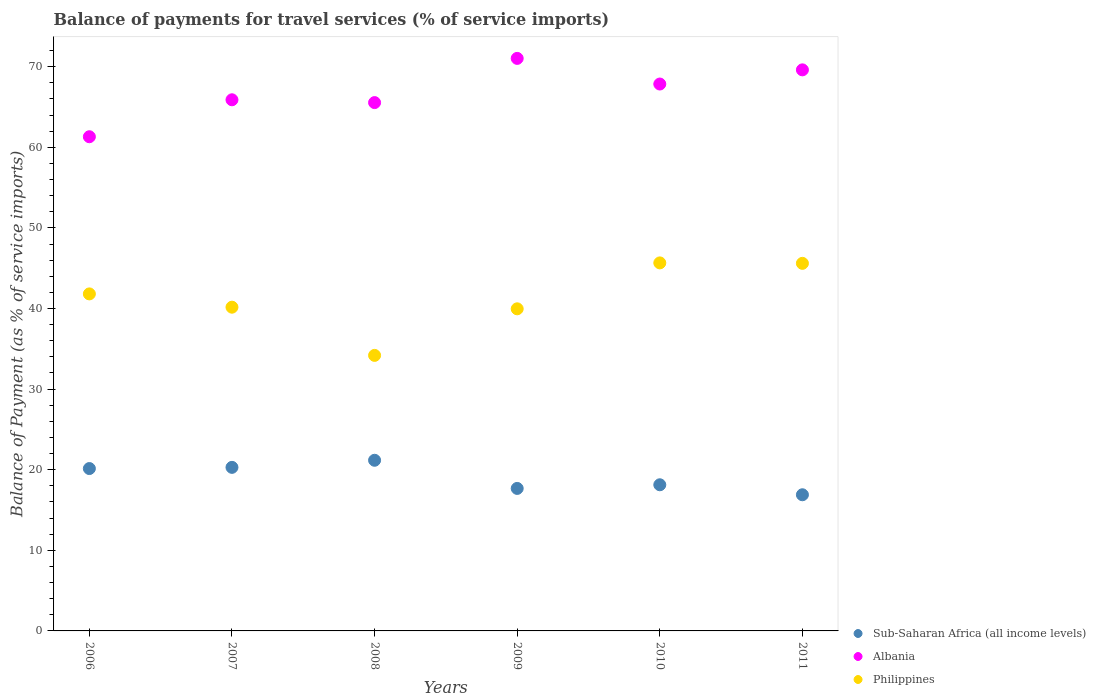What is the balance of payments for travel services in Philippines in 2007?
Provide a short and direct response. 40.16. Across all years, what is the maximum balance of payments for travel services in Philippines?
Ensure brevity in your answer.  45.66. Across all years, what is the minimum balance of payments for travel services in Sub-Saharan Africa (all income levels)?
Provide a short and direct response. 16.89. In which year was the balance of payments for travel services in Albania maximum?
Provide a short and direct response. 2009. What is the total balance of payments for travel services in Sub-Saharan Africa (all income levels) in the graph?
Your answer should be very brief. 114.31. What is the difference between the balance of payments for travel services in Philippines in 2009 and that in 2010?
Provide a short and direct response. -5.7. What is the difference between the balance of payments for travel services in Philippines in 2006 and the balance of payments for travel services in Albania in 2009?
Offer a terse response. -29.22. What is the average balance of payments for travel services in Philippines per year?
Provide a short and direct response. 41.23. In the year 2010, what is the difference between the balance of payments for travel services in Philippines and balance of payments for travel services in Sub-Saharan Africa (all income levels)?
Make the answer very short. 27.53. What is the ratio of the balance of payments for travel services in Philippines in 2007 to that in 2009?
Make the answer very short. 1.01. Is the balance of payments for travel services in Sub-Saharan Africa (all income levels) in 2007 less than that in 2008?
Provide a short and direct response. Yes. Is the difference between the balance of payments for travel services in Philippines in 2006 and 2011 greater than the difference between the balance of payments for travel services in Sub-Saharan Africa (all income levels) in 2006 and 2011?
Your response must be concise. No. What is the difference between the highest and the second highest balance of payments for travel services in Sub-Saharan Africa (all income levels)?
Ensure brevity in your answer.  0.88. What is the difference between the highest and the lowest balance of payments for travel services in Sub-Saharan Africa (all income levels)?
Offer a very short reply. 4.28. Does the balance of payments for travel services in Philippines monotonically increase over the years?
Make the answer very short. No. Is the balance of payments for travel services in Philippines strictly greater than the balance of payments for travel services in Sub-Saharan Africa (all income levels) over the years?
Your answer should be compact. Yes. Is the balance of payments for travel services in Philippines strictly less than the balance of payments for travel services in Sub-Saharan Africa (all income levels) over the years?
Ensure brevity in your answer.  No. How many years are there in the graph?
Provide a succinct answer. 6. Does the graph contain grids?
Ensure brevity in your answer.  No. Where does the legend appear in the graph?
Keep it short and to the point. Bottom right. How many legend labels are there?
Keep it short and to the point. 3. What is the title of the graph?
Offer a very short reply. Balance of payments for travel services (% of service imports). What is the label or title of the X-axis?
Your answer should be very brief. Years. What is the label or title of the Y-axis?
Make the answer very short. Balance of Payment (as % of service imports). What is the Balance of Payment (as % of service imports) in Sub-Saharan Africa (all income levels) in 2006?
Your answer should be very brief. 20.14. What is the Balance of Payment (as % of service imports) of Albania in 2006?
Offer a terse response. 61.31. What is the Balance of Payment (as % of service imports) in Philippines in 2006?
Offer a very short reply. 41.81. What is the Balance of Payment (as % of service imports) of Sub-Saharan Africa (all income levels) in 2007?
Provide a succinct answer. 20.29. What is the Balance of Payment (as % of service imports) of Albania in 2007?
Offer a very short reply. 65.89. What is the Balance of Payment (as % of service imports) of Philippines in 2007?
Keep it short and to the point. 40.16. What is the Balance of Payment (as % of service imports) in Sub-Saharan Africa (all income levels) in 2008?
Provide a succinct answer. 21.17. What is the Balance of Payment (as % of service imports) in Albania in 2008?
Your answer should be compact. 65.54. What is the Balance of Payment (as % of service imports) in Philippines in 2008?
Your answer should be compact. 34.18. What is the Balance of Payment (as % of service imports) in Sub-Saharan Africa (all income levels) in 2009?
Keep it short and to the point. 17.68. What is the Balance of Payment (as % of service imports) in Albania in 2009?
Ensure brevity in your answer.  71.03. What is the Balance of Payment (as % of service imports) of Philippines in 2009?
Your answer should be very brief. 39.96. What is the Balance of Payment (as % of service imports) of Sub-Saharan Africa (all income levels) in 2010?
Give a very brief answer. 18.13. What is the Balance of Payment (as % of service imports) of Albania in 2010?
Your answer should be very brief. 67.85. What is the Balance of Payment (as % of service imports) in Philippines in 2010?
Make the answer very short. 45.66. What is the Balance of Payment (as % of service imports) of Sub-Saharan Africa (all income levels) in 2011?
Offer a terse response. 16.89. What is the Balance of Payment (as % of service imports) in Albania in 2011?
Your answer should be very brief. 69.61. What is the Balance of Payment (as % of service imports) of Philippines in 2011?
Your answer should be compact. 45.6. Across all years, what is the maximum Balance of Payment (as % of service imports) in Sub-Saharan Africa (all income levels)?
Offer a terse response. 21.17. Across all years, what is the maximum Balance of Payment (as % of service imports) in Albania?
Provide a short and direct response. 71.03. Across all years, what is the maximum Balance of Payment (as % of service imports) of Philippines?
Your answer should be very brief. 45.66. Across all years, what is the minimum Balance of Payment (as % of service imports) in Sub-Saharan Africa (all income levels)?
Provide a succinct answer. 16.89. Across all years, what is the minimum Balance of Payment (as % of service imports) of Albania?
Keep it short and to the point. 61.31. Across all years, what is the minimum Balance of Payment (as % of service imports) in Philippines?
Offer a very short reply. 34.18. What is the total Balance of Payment (as % of service imports) of Sub-Saharan Africa (all income levels) in the graph?
Offer a very short reply. 114.31. What is the total Balance of Payment (as % of service imports) in Albania in the graph?
Keep it short and to the point. 401.23. What is the total Balance of Payment (as % of service imports) in Philippines in the graph?
Keep it short and to the point. 247.38. What is the difference between the Balance of Payment (as % of service imports) in Sub-Saharan Africa (all income levels) in 2006 and that in 2007?
Provide a succinct answer. -0.15. What is the difference between the Balance of Payment (as % of service imports) in Albania in 2006 and that in 2007?
Keep it short and to the point. -4.58. What is the difference between the Balance of Payment (as % of service imports) of Philippines in 2006 and that in 2007?
Make the answer very short. 1.65. What is the difference between the Balance of Payment (as % of service imports) in Sub-Saharan Africa (all income levels) in 2006 and that in 2008?
Your response must be concise. -1.03. What is the difference between the Balance of Payment (as % of service imports) of Albania in 2006 and that in 2008?
Ensure brevity in your answer.  -4.24. What is the difference between the Balance of Payment (as % of service imports) of Philippines in 2006 and that in 2008?
Keep it short and to the point. 7.63. What is the difference between the Balance of Payment (as % of service imports) of Sub-Saharan Africa (all income levels) in 2006 and that in 2009?
Your answer should be very brief. 2.47. What is the difference between the Balance of Payment (as % of service imports) of Albania in 2006 and that in 2009?
Give a very brief answer. -9.72. What is the difference between the Balance of Payment (as % of service imports) in Philippines in 2006 and that in 2009?
Provide a succinct answer. 1.85. What is the difference between the Balance of Payment (as % of service imports) in Sub-Saharan Africa (all income levels) in 2006 and that in 2010?
Offer a very short reply. 2.01. What is the difference between the Balance of Payment (as % of service imports) of Albania in 2006 and that in 2010?
Provide a succinct answer. -6.54. What is the difference between the Balance of Payment (as % of service imports) in Philippines in 2006 and that in 2010?
Your answer should be compact. -3.85. What is the difference between the Balance of Payment (as % of service imports) in Sub-Saharan Africa (all income levels) in 2006 and that in 2011?
Offer a very short reply. 3.25. What is the difference between the Balance of Payment (as % of service imports) of Albania in 2006 and that in 2011?
Provide a succinct answer. -8.3. What is the difference between the Balance of Payment (as % of service imports) of Philippines in 2006 and that in 2011?
Your answer should be compact. -3.79. What is the difference between the Balance of Payment (as % of service imports) of Sub-Saharan Africa (all income levels) in 2007 and that in 2008?
Make the answer very short. -0.88. What is the difference between the Balance of Payment (as % of service imports) of Albania in 2007 and that in 2008?
Keep it short and to the point. 0.35. What is the difference between the Balance of Payment (as % of service imports) in Philippines in 2007 and that in 2008?
Offer a terse response. 5.98. What is the difference between the Balance of Payment (as % of service imports) of Sub-Saharan Africa (all income levels) in 2007 and that in 2009?
Make the answer very short. 2.61. What is the difference between the Balance of Payment (as % of service imports) of Albania in 2007 and that in 2009?
Your answer should be compact. -5.14. What is the difference between the Balance of Payment (as % of service imports) of Philippines in 2007 and that in 2009?
Offer a very short reply. 0.2. What is the difference between the Balance of Payment (as % of service imports) in Sub-Saharan Africa (all income levels) in 2007 and that in 2010?
Keep it short and to the point. 2.16. What is the difference between the Balance of Payment (as % of service imports) in Albania in 2007 and that in 2010?
Ensure brevity in your answer.  -1.96. What is the difference between the Balance of Payment (as % of service imports) of Philippines in 2007 and that in 2010?
Your answer should be compact. -5.5. What is the difference between the Balance of Payment (as % of service imports) of Sub-Saharan Africa (all income levels) in 2007 and that in 2011?
Give a very brief answer. 3.4. What is the difference between the Balance of Payment (as % of service imports) of Albania in 2007 and that in 2011?
Your response must be concise. -3.71. What is the difference between the Balance of Payment (as % of service imports) of Philippines in 2007 and that in 2011?
Offer a terse response. -5.44. What is the difference between the Balance of Payment (as % of service imports) of Sub-Saharan Africa (all income levels) in 2008 and that in 2009?
Offer a very short reply. 3.49. What is the difference between the Balance of Payment (as % of service imports) in Albania in 2008 and that in 2009?
Ensure brevity in your answer.  -5.48. What is the difference between the Balance of Payment (as % of service imports) in Philippines in 2008 and that in 2009?
Ensure brevity in your answer.  -5.78. What is the difference between the Balance of Payment (as % of service imports) in Sub-Saharan Africa (all income levels) in 2008 and that in 2010?
Offer a very short reply. 3.04. What is the difference between the Balance of Payment (as % of service imports) in Albania in 2008 and that in 2010?
Offer a very short reply. -2.3. What is the difference between the Balance of Payment (as % of service imports) in Philippines in 2008 and that in 2010?
Offer a terse response. -11.48. What is the difference between the Balance of Payment (as % of service imports) of Sub-Saharan Africa (all income levels) in 2008 and that in 2011?
Keep it short and to the point. 4.28. What is the difference between the Balance of Payment (as % of service imports) of Albania in 2008 and that in 2011?
Provide a succinct answer. -4.06. What is the difference between the Balance of Payment (as % of service imports) of Philippines in 2008 and that in 2011?
Provide a succinct answer. -11.42. What is the difference between the Balance of Payment (as % of service imports) of Sub-Saharan Africa (all income levels) in 2009 and that in 2010?
Provide a succinct answer. -0.45. What is the difference between the Balance of Payment (as % of service imports) of Albania in 2009 and that in 2010?
Keep it short and to the point. 3.18. What is the difference between the Balance of Payment (as % of service imports) of Philippines in 2009 and that in 2010?
Give a very brief answer. -5.7. What is the difference between the Balance of Payment (as % of service imports) in Sub-Saharan Africa (all income levels) in 2009 and that in 2011?
Provide a short and direct response. 0.79. What is the difference between the Balance of Payment (as % of service imports) of Albania in 2009 and that in 2011?
Offer a terse response. 1.42. What is the difference between the Balance of Payment (as % of service imports) in Philippines in 2009 and that in 2011?
Your answer should be compact. -5.64. What is the difference between the Balance of Payment (as % of service imports) of Sub-Saharan Africa (all income levels) in 2010 and that in 2011?
Provide a short and direct response. 1.24. What is the difference between the Balance of Payment (as % of service imports) in Albania in 2010 and that in 2011?
Ensure brevity in your answer.  -1.76. What is the difference between the Balance of Payment (as % of service imports) of Philippines in 2010 and that in 2011?
Your answer should be compact. 0.06. What is the difference between the Balance of Payment (as % of service imports) in Sub-Saharan Africa (all income levels) in 2006 and the Balance of Payment (as % of service imports) in Albania in 2007?
Ensure brevity in your answer.  -45.75. What is the difference between the Balance of Payment (as % of service imports) of Sub-Saharan Africa (all income levels) in 2006 and the Balance of Payment (as % of service imports) of Philippines in 2007?
Your response must be concise. -20.02. What is the difference between the Balance of Payment (as % of service imports) of Albania in 2006 and the Balance of Payment (as % of service imports) of Philippines in 2007?
Offer a very short reply. 21.15. What is the difference between the Balance of Payment (as % of service imports) in Sub-Saharan Africa (all income levels) in 2006 and the Balance of Payment (as % of service imports) in Albania in 2008?
Your answer should be very brief. -45.4. What is the difference between the Balance of Payment (as % of service imports) in Sub-Saharan Africa (all income levels) in 2006 and the Balance of Payment (as % of service imports) in Philippines in 2008?
Your response must be concise. -14.04. What is the difference between the Balance of Payment (as % of service imports) of Albania in 2006 and the Balance of Payment (as % of service imports) of Philippines in 2008?
Offer a terse response. 27.13. What is the difference between the Balance of Payment (as % of service imports) of Sub-Saharan Africa (all income levels) in 2006 and the Balance of Payment (as % of service imports) of Albania in 2009?
Provide a succinct answer. -50.88. What is the difference between the Balance of Payment (as % of service imports) in Sub-Saharan Africa (all income levels) in 2006 and the Balance of Payment (as % of service imports) in Philippines in 2009?
Provide a succinct answer. -19.82. What is the difference between the Balance of Payment (as % of service imports) in Albania in 2006 and the Balance of Payment (as % of service imports) in Philippines in 2009?
Provide a short and direct response. 21.35. What is the difference between the Balance of Payment (as % of service imports) of Sub-Saharan Africa (all income levels) in 2006 and the Balance of Payment (as % of service imports) of Albania in 2010?
Ensure brevity in your answer.  -47.7. What is the difference between the Balance of Payment (as % of service imports) in Sub-Saharan Africa (all income levels) in 2006 and the Balance of Payment (as % of service imports) in Philippines in 2010?
Keep it short and to the point. -25.51. What is the difference between the Balance of Payment (as % of service imports) in Albania in 2006 and the Balance of Payment (as % of service imports) in Philippines in 2010?
Keep it short and to the point. 15.65. What is the difference between the Balance of Payment (as % of service imports) of Sub-Saharan Africa (all income levels) in 2006 and the Balance of Payment (as % of service imports) of Albania in 2011?
Ensure brevity in your answer.  -49.46. What is the difference between the Balance of Payment (as % of service imports) in Sub-Saharan Africa (all income levels) in 2006 and the Balance of Payment (as % of service imports) in Philippines in 2011?
Offer a very short reply. -25.46. What is the difference between the Balance of Payment (as % of service imports) in Albania in 2006 and the Balance of Payment (as % of service imports) in Philippines in 2011?
Ensure brevity in your answer.  15.71. What is the difference between the Balance of Payment (as % of service imports) of Sub-Saharan Africa (all income levels) in 2007 and the Balance of Payment (as % of service imports) of Albania in 2008?
Ensure brevity in your answer.  -45.25. What is the difference between the Balance of Payment (as % of service imports) in Sub-Saharan Africa (all income levels) in 2007 and the Balance of Payment (as % of service imports) in Philippines in 2008?
Make the answer very short. -13.89. What is the difference between the Balance of Payment (as % of service imports) of Albania in 2007 and the Balance of Payment (as % of service imports) of Philippines in 2008?
Offer a terse response. 31.71. What is the difference between the Balance of Payment (as % of service imports) in Sub-Saharan Africa (all income levels) in 2007 and the Balance of Payment (as % of service imports) in Albania in 2009?
Make the answer very short. -50.74. What is the difference between the Balance of Payment (as % of service imports) in Sub-Saharan Africa (all income levels) in 2007 and the Balance of Payment (as % of service imports) in Philippines in 2009?
Provide a succinct answer. -19.67. What is the difference between the Balance of Payment (as % of service imports) in Albania in 2007 and the Balance of Payment (as % of service imports) in Philippines in 2009?
Your answer should be very brief. 25.93. What is the difference between the Balance of Payment (as % of service imports) in Sub-Saharan Africa (all income levels) in 2007 and the Balance of Payment (as % of service imports) in Albania in 2010?
Provide a short and direct response. -47.56. What is the difference between the Balance of Payment (as % of service imports) of Sub-Saharan Africa (all income levels) in 2007 and the Balance of Payment (as % of service imports) of Philippines in 2010?
Provide a succinct answer. -25.37. What is the difference between the Balance of Payment (as % of service imports) of Albania in 2007 and the Balance of Payment (as % of service imports) of Philippines in 2010?
Ensure brevity in your answer.  20.23. What is the difference between the Balance of Payment (as % of service imports) in Sub-Saharan Africa (all income levels) in 2007 and the Balance of Payment (as % of service imports) in Albania in 2011?
Offer a terse response. -49.31. What is the difference between the Balance of Payment (as % of service imports) in Sub-Saharan Africa (all income levels) in 2007 and the Balance of Payment (as % of service imports) in Philippines in 2011?
Provide a short and direct response. -25.31. What is the difference between the Balance of Payment (as % of service imports) in Albania in 2007 and the Balance of Payment (as % of service imports) in Philippines in 2011?
Your answer should be very brief. 20.29. What is the difference between the Balance of Payment (as % of service imports) in Sub-Saharan Africa (all income levels) in 2008 and the Balance of Payment (as % of service imports) in Albania in 2009?
Make the answer very short. -49.86. What is the difference between the Balance of Payment (as % of service imports) of Sub-Saharan Africa (all income levels) in 2008 and the Balance of Payment (as % of service imports) of Philippines in 2009?
Make the answer very short. -18.79. What is the difference between the Balance of Payment (as % of service imports) in Albania in 2008 and the Balance of Payment (as % of service imports) in Philippines in 2009?
Provide a short and direct response. 25.58. What is the difference between the Balance of Payment (as % of service imports) of Sub-Saharan Africa (all income levels) in 2008 and the Balance of Payment (as % of service imports) of Albania in 2010?
Your answer should be very brief. -46.68. What is the difference between the Balance of Payment (as % of service imports) in Sub-Saharan Africa (all income levels) in 2008 and the Balance of Payment (as % of service imports) in Philippines in 2010?
Offer a terse response. -24.49. What is the difference between the Balance of Payment (as % of service imports) of Albania in 2008 and the Balance of Payment (as % of service imports) of Philippines in 2010?
Make the answer very short. 19.89. What is the difference between the Balance of Payment (as % of service imports) of Sub-Saharan Africa (all income levels) in 2008 and the Balance of Payment (as % of service imports) of Albania in 2011?
Offer a terse response. -48.43. What is the difference between the Balance of Payment (as % of service imports) in Sub-Saharan Africa (all income levels) in 2008 and the Balance of Payment (as % of service imports) in Philippines in 2011?
Your answer should be very brief. -24.43. What is the difference between the Balance of Payment (as % of service imports) in Albania in 2008 and the Balance of Payment (as % of service imports) in Philippines in 2011?
Your answer should be compact. 19.94. What is the difference between the Balance of Payment (as % of service imports) of Sub-Saharan Africa (all income levels) in 2009 and the Balance of Payment (as % of service imports) of Albania in 2010?
Keep it short and to the point. -50.17. What is the difference between the Balance of Payment (as % of service imports) in Sub-Saharan Africa (all income levels) in 2009 and the Balance of Payment (as % of service imports) in Philippines in 2010?
Your answer should be compact. -27.98. What is the difference between the Balance of Payment (as % of service imports) in Albania in 2009 and the Balance of Payment (as % of service imports) in Philippines in 2010?
Provide a succinct answer. 25.37. What is the difference between the Balance of Payment (as % of service imports) of Sub-Saharan Africa (all income levels) in 2009 and the Balance of Payment (as % of service imports) of Albania in 2011?
Your answer should be very brief. -51.93. What is the difference between the Balance of Payment (as % of service imports) in Sub-Saharan Africa (all income levels) in 2009 and the Balance of Payment (as % of service imports) in Philippines in 2011?
Make the answer very short. -27.92. What is the difference between the Balance of Payment (as % of service imports) of Albania in 2009 and the Balance of Payment (as % of service imports) of Philippines in 2011?
Your answer should be very brief. 25.43. What is the difference between the Balance of Payment (as % of service imports) of Sub-Saharan Africa (all income levels) in 2010 and the Balance of Payment (as % of service imports) of Albania in 2011?
Make the answer very short. -51.48. What is the difference between the Balance of Payment (as % of service imports) of Sub-Saharan Africa (all income levels) in 2010 and the Balance of Payment (as % of service imports) of Philippines in 2011?
Give a very brief answer. -27.47. What is the difference between the Balance of Payment (as % of service imports) of Albania in 2010 and the Balance of Payment (as % of service imports) of Philippines in 2011?
Your answer should be compact. 22.25. What is the average Balance of Payment (as % of service imports) in Sub-Saharan Africa (all income levels) per year?
Offer a very short reply. 19.05. What is the average Balance of Payment (as % of service imports) of Albania per year?
Give a very brief answer. 66.87. What is the average Balance of Payment (as % of service imports) in Philippines per year?
Provide a succinct answer. 41.23. In the year 2006, what is the difference between the Balance of Payment (as % of service imports) in Sub-Saharan Africa (all income levels) and Balance of Payment (as % of service imports) in Albania?
Offer a very short reply. -41.16. In the year 2006, what is the difference between the Balance of Payment (as % of service imports) in Sub-Saharan Africa (all income levels) and Balance of Payment (as % of service imports) in Philippines?
Your answer should be very brief. -21.67. In the year 2006, what is the difference between the Balance of Payment (as % of service imports) in Albania and Balance of Payment (as % of service imports) in Philippines?
Give a very brief answer. 19.5. In the year 2007, what is the difference between the Balance of Payment (as % of service imports) of Sub-Saharan Africa (all income levels) and Balance of Payment (as % of service imports) of Albania?
Your response must be concise. -45.6. In the year 2007, what is the difference between the Balance of Payment (as % of service imports) of Sub-Saharan Africa (all income levels) and Balance of Payment (as % of service imports) of Philippines?
Provide a short and direct response. -19.87. In the year 2007, what is the difference between the Balance of Payment (as % of service imports) of Albania and Balance of Payment (as % of service imports) of Philippines?
Provide a short and direct response. 25.73. In the year 2008, what is the difference between the Balance of Payment (as % of service imports) in Sub-Saharan Africa (all income levels) and Balance of Payment (as % of service imports) in Albania?
Provide a succinct answer. -44.37. In the year 2008, what is the difference between the Balance of Payment (as % of service imports) in Sub-Saharan Africa (all income levels) and Balance of Payment (as % of service imports) in Philippines?
Your answer should be very brief. -13.01. In the year 2008, what is the difference between the Balance of Payment (as % of service imports) of Albania and Balance of Payment (as % of service imports) of Philippines?
Provide a succinct answer. 31.36. In the year 2009, what is the difference between the Balance of Payment (as % of service imports) of Sub-Saharan Africa (all income levels) and Balance of Payment (as % of service imports) of Albania?
Provide a succinct answer. -53.35. In the year 2009, what is the difference between the Balance of Payment (as % of service imports) of Sub-Saharan Africa (all income levels) and Balance of Payment (as % of service imports) of Philippines?
Ensure brevity in your answer.  -22.28. In the year 2009, what is the difference between the Balance of Payment (as % of service imports) of Albania and Balance of Payment (as % of service imports) of Philippines?
Make the answer very short. 31.07. In the year 2010, what is the difference between the Balance of Payment (as % of service imports) of Sub-Saharan Africa (all income levels) and Balance of Payment (as % of service imports) of Albania?
Provide a short and direct response. -49.72. In the year 2010, what is the difference between the Balance of Payment (as % of service imports) of Sub-Saharan Africa (all income levels) and Balance of Payment (as % of service imports) of Philippines?
Give a very brief answer. -27.53. In the year 2010, what is the difference between the Balance of Payment (as % of service imports) of Albania and Balance of Payment (as % of service imports) of Philippines?
Keep it short and to the point. 22.19. In the year 2011, what is the difference between the Balance of Payment (as % of service imports) in Sub-Saharan Africa (all income levels) and Balance of Payment (as % of service imports) in Albania?
Your answer should be very brief. -52.71. In the year 2011, what is the difference between the Balance of Payment (as % of service imports) in Sub-Saharan Africa (all income levels) and Balance of Payment (as % of service imports) in Philippines?
Offer a very short reply. -28.71. In the year 2011, what is the difference between the Balance of Payment (as % of service imports) of Albania and Balance of Payment (as % of service imports) of Philippines?
Keep it short and to the point. 24. What is the ratio of the Balance of Payment (as % of service imports) of Sub-Saharan Africa (all income levels) in 2006 to that in 2007?
Your answer should be compact. 0.99. What is the ratio of the Balance of Payment (as % of service imports) of Albania in 2006 to that in 2007?
Your answer should be compact. 0.93. What is the ratio of the Balance of Payment (as % of service imports) of Philippines in 2006 to that in 2007?
Your answer should be very brief. 1.04. What is the ratio of the Balance of Payment (as % of service imports) of Sub-Saharan Africa (all income levels) in 2006 to that in 2008?
Your response must be concise. 0.95. What is the ratio of the Balance of Payment (as % of service imports) of Albania in 2006 to that in 2008?
Your response must be concise. 0.94. What is the ratio of the Balance of Payment (as % of service imports) of Philippines in 2006 to that in 2008?
Provide a succinct answer. 1.22. What is the ratio of the Balance of Payment (as % of service imports) in Sub-Saharan Africa (all income levels) in 2006 to that in 2009?
Offer a very short reply. 1.14. What is the ratio of the Balance of Payment (as % of service imports) in Albania in 2006 to that in 2009?
Provide a short and direct response. 0.86. What is the ratio of the Balance of Payment (as % of service imports) in Philippines in 2006 to that in 2009?
Keep it short and to the point. 1.05. What is the ratio of the Balance of Payment (as % of service imports) of Sub-Saharan Africa (all income levels) in 2006 to that in 2010?
Give a very brief answer. 1.11. What is the ratio of the Balance of Payment (as % of service imports) in Albania in 2006 to that in 2010?
Keep it short and to the point. 0.9. What is the ratio of the Balance of Payment (as % of service imports) in Philippines in 2006 to that in 2010?
Offer a terse response. 0.92. What is the ratio of the Balance of Payment (as % of service imports) of Sub-Saharan Africa (all income levels) in 2006 to that in 2011?
Provide a short and direct response. 1.19. What is the ratio of the Balance of Payment (as % of service imports) of Albania in 2006 to that in 2011?
Give a very brief answer. 0.88. What is the ratio of the Balance of Payment (as % of service imports) in Philippines in 2006 to that in 2011?
Ensure brevity in your answer.  0.92. What is the ratio of the Balance of Payment (as % of service imports) in Sub-Saharan Africa (all income levels) in 2007 to that in 2008?
Give a very brief answer. 0.96. What is the ratio of the Balance of Payment (as % of service imports) in Albania in 2007 to that in 2008?
Give a very brief answer. 1.01. What is the ratio of the Balance of Payment (as % of service imports) of Philippines in 2007 to that in 2008?
Make the answer very short. 1.17. What is the ratio of the Balance of Payment (as % of service imports) of Sub-Saharan Africa (all income levels) in 2007 to that in 2009?
Your response must be concise. 1.15. What is the ratio of the Balance of Payment (as % of service imports) of Albania in 2007 to that in 2009?
Give a very brief answer. 0.93. What is the ratio of the Balance of Payment (as % of service imports) of Sub-Saharan Africa (all income levels) in 2007 to that in 2010?
Provide a short and direct response. 1.12. What is the ratio of the Balance of Payment (as % of service imports) in Albania in 2007 to that in 2010?
Make the answer very short. 0.97. What is the ratio of the Balance of Payment (as % of service imports) of Philippines in 2007 to that in 2010?
Make the answer very short. 0.88. What is the ratio of the Balance of Payment (as % of service imports) of Sub-Saharan Africa (all income levels) in 2007 to that in 2011?
Offer a terse response. 1.2. What is the ratio of the Balance of Payment (as % of service imports) in Albania in 2007 to that in 2011?
Provide a succinct answer. 0.95. What is the ratio of the Balance of Payment (as % of service imports) in Philippines in 2007 to that in 2011?
Keep it short and to the point. 0.88. What is the ratio of the Balance of Payment (as % of service imports) of Sub-Saharan Africa (all income levels) in 2008 to that in 2009?
Provide a succinct answer. 1.2. What is the ratio of the Balance of Payment (as % of service imports) in Albania in 2008 to that in 2009?
Make the answer very short. 0.92. What is the ratio of the Balance of Payment (as % of service imports) of Philippines in 2008 to that in 2009?
Keep it short and to the point. 0.86. What is the ratio of the Balance of Payment (as % of service imports) of Sub-Saharan Africa (all income levels) in 2008 to that in 2010?
Your response must be concise. 1.17. What is the ratio of the Balance of Payment (as % of service imports) in Albania in 2008 to that in 2010?
Provide a succinct answer. 0.97. What is the ratio of the Balance of Payment (as % of service imports) in Philippines in 2008 to that in 2010?
Give a very brief answer. 0.75. What is the ratio of the Balance of Payment (as % of service imports) of Sub-Saharan Africa (all income levels) in 2008 to that in 2011?
Offer a very short reply. 1.25. What is the ratio of the Balance of Payment (as % of service imports) in Albania in 2008 to that in 2011?
Keep it short and to the point. 0.94. What is the ratio of the Balance of Payment (as % of service imports) of Philippines in 2008 to that in 2011?
Your answer should be compact. 0.75. What is the ratio of the Balance of Payment (as % of service imports) of Albania in 2009 to that in 2010?
Your answer should be very brief. 1.05. What is the ratio of the Balance of Payment (as % of service imports) in Philippines in 2009 to that in 2010?
Give a very brief answer. 0.88. What is the ratio of the Balance of Payment (as % of service imports) in Sub-Saharan Africa (all income levels) in 2009 to that in 2011?
Provide a short and direct response. 1.05. What is the ratio of the Balance of Payment (as % of service imports) in Albania in 2009 to that in 2011?
Your response must be concise. 1.02. What is the ratio of the Balance of Payment (as % of service imports) of Philippines in 2009 to that in 2011?
Keep it short and to the point. 0.88. What is the ratio of the Balance of Payment (as % of service imports) in Sub-Saharan Africa (all income levels) in 2010 to that in 2011?
Offer a terse response. 1.07. What is the ratio of the Balance of Payment (as % of service imports) of Albania in 2010 to that in 2011?
Provide a succinct answer. 0.97. What is the ratio of the Balance of Payment (as % of service imports) of Philippines in 2010 to that in 2011?
Keep it short and to the point. 1. What is the difference between the highest and the second highest Balance of Payment (as % of service imports) in Sub-Saharan Africa (all income levels)?
Give a very brief answer. 0.88. What is the difference between the highest and the second highest Balance of Payment (as % of service imports) in Albania?
Offer a very short reply. 1.42. What is the difference between the highest and the second highest Balance of Payment (as % of service imports) in Philippines?
Make the answer very short. 0.06. What is the difference between the highest and the lowest Balance of Payment (as % of service imports) of Sub-Saharan Africa (all income levels)?
Your response must be concise. 4.28. What is the difference between the highest and the lowest Balance of Payment (as % of service imports) in Albania?
Your response must be concise. 9.72. What is the difference between the highest and the lowest Balance of Payment (as % of service imports) in Philippines?
Provide a succinct answer. 11.48. 